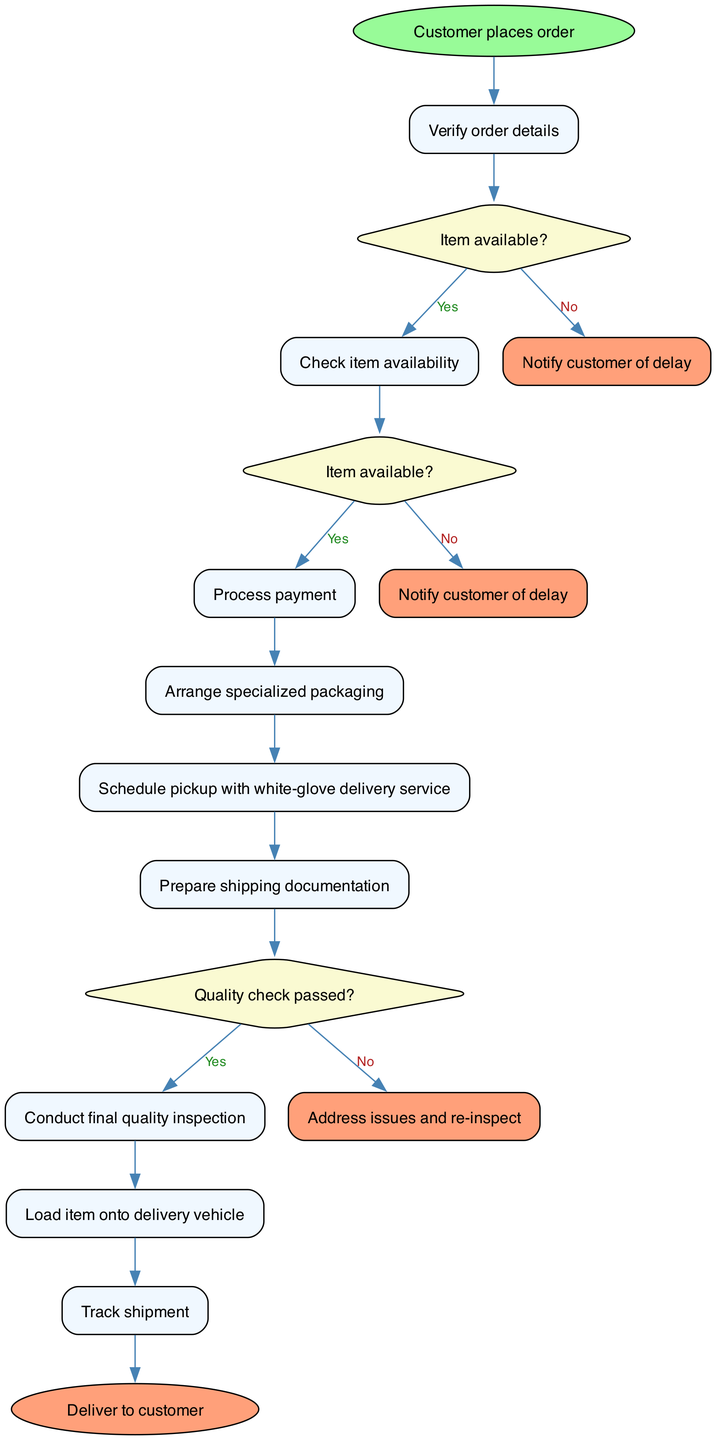What is the initial node in the diagram? The initial node is explicitly stated as "Customer places order." This is the starting point of the activity diagram, indicating the commencement of the order processing.
Answer: Customer places order What follows after verifying order details? After "Verify order details," the next activity is "Check item availability." This follows the flow of the diagram directly from the first activity.
Answer: Check item availability How many activities are there in total? There are eight activities listed in the diagram, which include various steps in the order processing flow. Counting each one confirms this total.
Answer: 8 What happens if the item is not available? If the item is not available, the flow directs to "Notify customer of delay." This is specified in the decision node related to availability.
Answer: Notify customer of delay What is the last activity before delivering the item? The last activity before reaching the final node "Deliver to customer" is "Load item onto delivery vehicle." This is the step just before delivery.
Answer: Load item onto delivery vehicle What is the consequence of an unsuccessful payment? An unsuccessful payment leads to "Cancel order." This outcome is specified in the decision node regarding payment success.
Answer: Cancel order Which activity occurs after "Conduct final quality inspection"? After "Conduct final quality inspection," the next activity is "Load item onto delivery vehicle." This is indicated by the flow from quality inspection to loading.
Answer: Load item onto delivery vehicle What condition is checked after arranging packaging? After arranging specialized packaging, the next check is about "Payment successful?" This is defined in the decision node directly following the packaging activity.
Answer: Payment successful? What is indicated by the "Quality check passed?" decision node? The "Quality check passed?" decision node determines whether the flow continues to "Load item onto delivery vehicle" or goes to addressing issues and re-inspection if failed.
Answer: Load item onto delivery vehicle or Address issues and re-inspect 